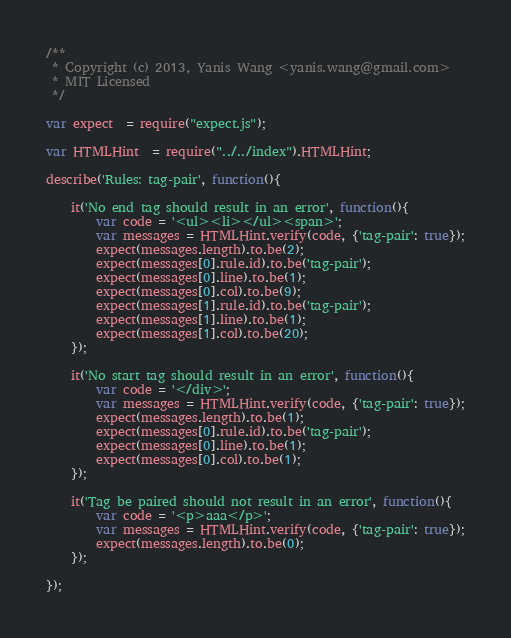Convert code to text. <code><loc_0><loc_0><loc_500><loc_500><_JavaScript_>/**
 * Copyright (c) 2013, Yanis Wang <yanis.wang@gmail.com>
 * MIT Licensed
 */

var expect  = require("expect.js");

var HTMLHint  = require("../../index").HTMLHint;

describe('Rules: tag-pair', function(){

    it('No end tag should result in an error', function(){
        var code = '<ul><li></ul><span>';
        var messages = HTMLHint.verify(code, {'tag-pair': true});
        expect(messages.length).to.be(2);
        expect(messages[0].rule.id).to.be('tag-pair');
        expect(messages[0].line).to.be(1);
        expect(messages[0].col).to.be(9);
        expect(messages[1].rule.id).to.be('tag-pair');
        expect(messages[1].line).to.be(1);
        expect(messages[1].col).to.be(20);
    });

    it('No start tag should result in an error', function(){
        var code = '</div>';
        var messages = HTMLHint.verify(code, {'tag-pair': true});
        expect(messages.length).to.be(1);
        expect(messages[0].rule.id).to.be('tag-pair');
        expect(messages[0].line).to.be(1);
        expect(messages[0].col).to.be(1);
    });

    it('Tag be paired should not result in an error', function(){
        var code = '<p>aaa</p>';
        var messages = HTMLHint.verify(code, {'tag-pair': true});
        expect(messages.length).to.be(0);
    });

});</code> 